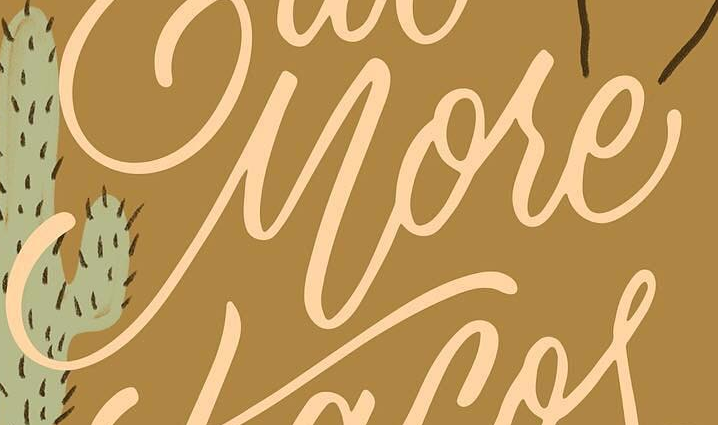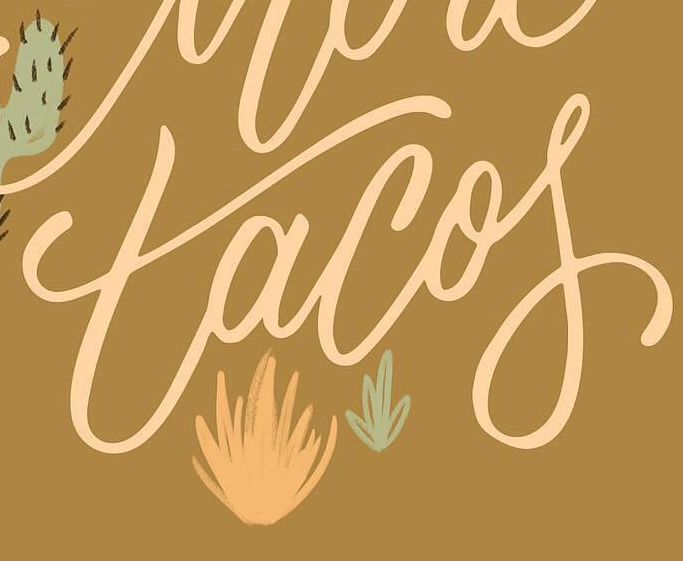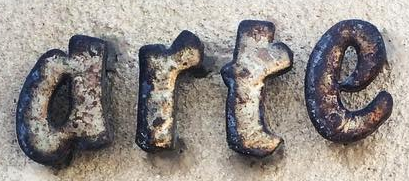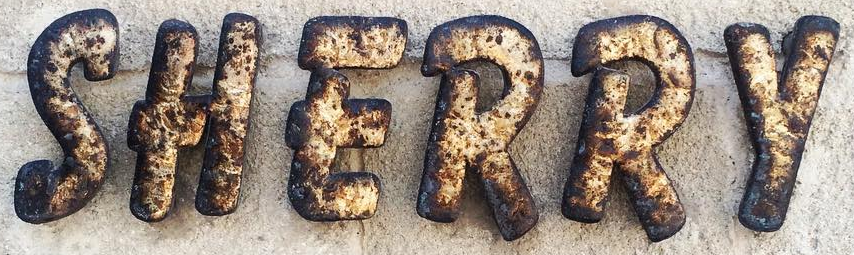Transcribe the words shown in these images in order, separated by a semicolon. More; tacof; arte; SHERRY 